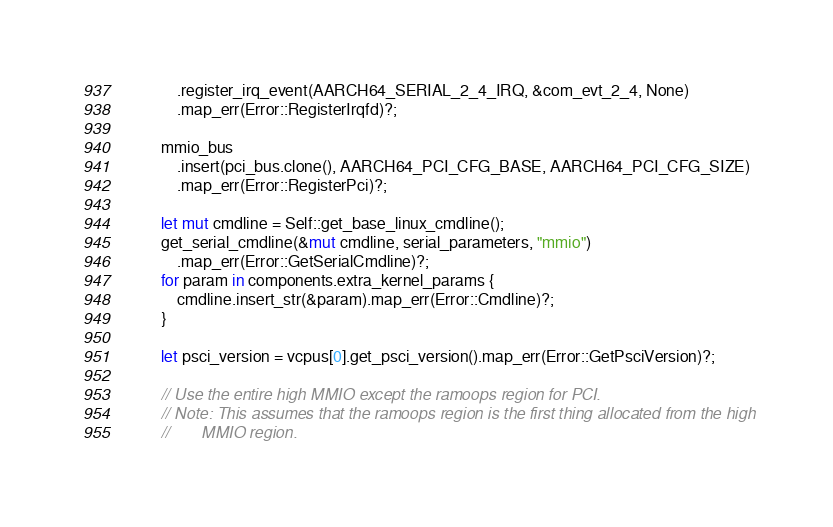Convert code to text. <code><loc_0><loc_0><loc_500><loc_500><_Rust_>            .register_irq_event(AARCH64_SERIAL_2_4_IRQ, &com_evt_2_4, None)
            .map_err(Error::RegisterIrqfd)?;

        mmio_bus
            .insert(pci_bus.clone(), AARCH64_PCI_CFG_BASE, AARCH64_PCI_CFG_SIZE)
            .map_err(Error::RegisterPci)?;

        let mut cmdline = Self::get_base_linux_cmdline();
        get_serial_cmdline(&mut cmdline, serial_parameters, "mmio")
            .map_err(Error::GetSerialCmdline)?;
        for param in components.extra_kernel_params {
            cmdline.insert_str(&param).map_err(Error::Cmdline)?;
        }

        let psci_version = vcpus[0].get_psci_version().map_err(Error::GetPsciVersion)?;

        // Use the entire high MMIO except the ramoops region for PCI.
        // Note: This assumes that the ramoops region is the first thing allocated from the high
        //       MMIO region.</code> 